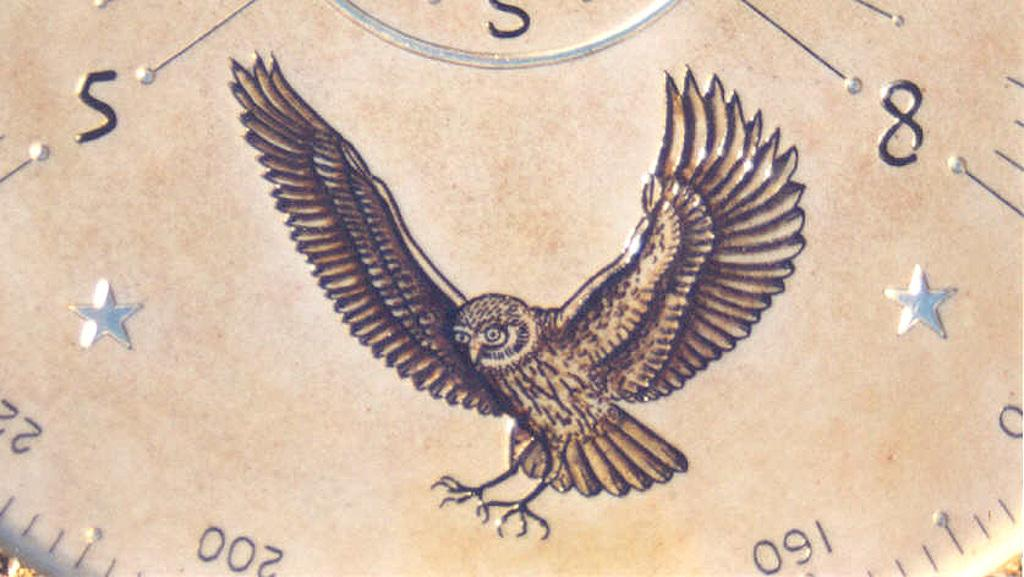What is depicted in the image? There is a drawing of a bird in the image. Can you describe any other elements in the image? There is a group of numbers in the background of the image. What level of difficulty does the bird represent in the image? The image does not indicate any level of difficulty for the bird; it is simply a drawing of a bird. 